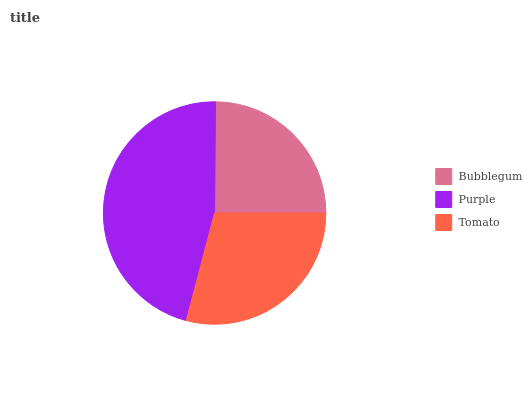Is Bubblegum the minimum?
Answer yes or no. Yes. Is Purple the maximum?
Answer yes or no. Yes. Is Tomato the minimum?
Answer yes or no. No. Is Tomato the maximum?
Answer yes or no. No. Is Purple greater than Tomato?
Answer yes or no. Yes. Is Tomato less than Purple?
Answer yes or no. Yes. Is Tomato greater than Purple?
Answer yes or no. No. Is Purple less than Tomato?
Answer yes or no. No. Is Tomato the high median?
Answer yes or no. Yes. Is Tomato the low median?
Answer yes or no. Yes. Is Purple the high median?
Answer yes or no. No. Is Bubblegum the low median?
Answer yes or no. No. 